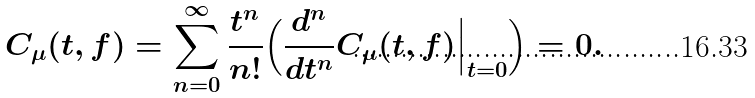<formula> <loc_0><loc_0><loc_500><loc_500>C _ { \mu } ( t , f ) = \sum _ { n = 0 } ^ { \infty } \frac { t ^ { n } } { n ! } \Big ( \frac { d ^ { n } } { d t ^ { n } } C _ { \mu } ( t , f ) \Big | _ { t = 0 } \Big ) = 0 .</formula> 